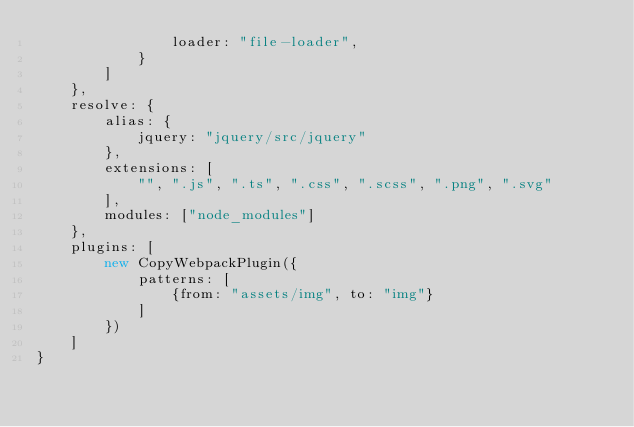<code> <loc_0><loc_0><loc_500><loc_500><_JavaScript_>                loader: "file-loader",
            }
        ]
    },
    resolve: {
        alias: {
            jquery: "jquery/src/jquery"
        },
        extensions: [
            "", ".js", ".ts", ".css", ".scss", ".png", ".svg"
        ],
        modules: ["node_modules"]
    },
    plugins: [
        new CopyWebpackPlugin({
            patterns: [
                {from: "assets/img", to: "img"}
            ]
        })
    ]
}</code> 